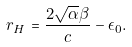Convert formula to latex. <formula><loc_0><loc_0><loc_500><loc_500>r _ { H } = \frac { 2 \sqrt { \alpha } \beta } { c } - \epsilon _ { 0 } .</formula> 